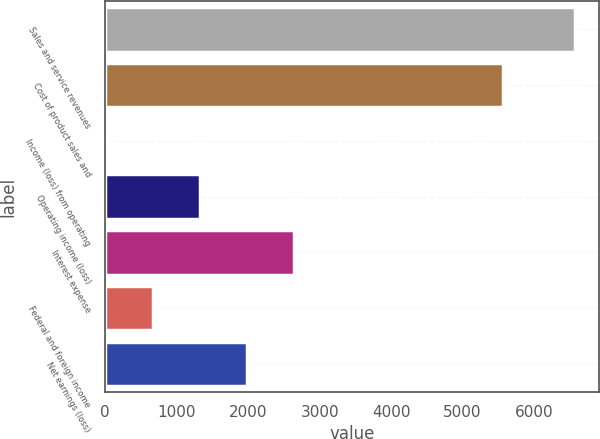Convert chart to OTSL. <chart><loc_0><loc_0><loc_500><loc_500><bar_chart><fcel>Sales and service revenues<fcel>Cost of product sales and<fcel>Income (loss) from operating<fcel>Operating income (loss)<fcel>Interest expense<fcel>Federal and foreign income<fcel>Net earnings (loss)<nl><fcel>6575<fcel>5571<fcel>20<fcel>1331<fcel>2642<fcel>675.5<fcel>1986.5<nl></chart> 